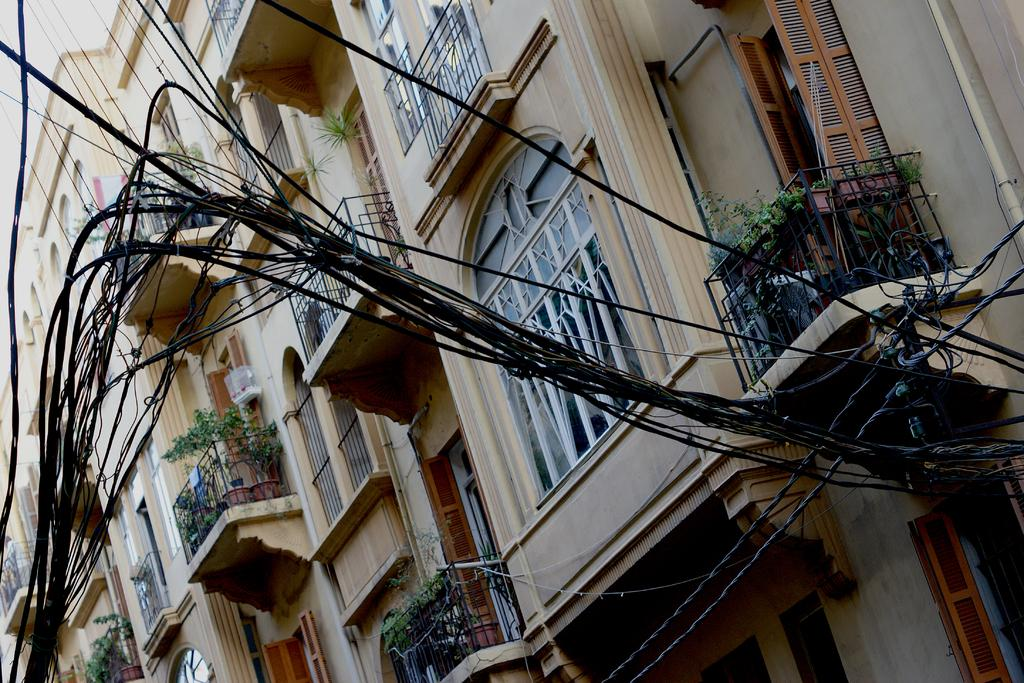What can be seen in the image that is related to electricity or communication? There are wires in the image. What is located behind the wires in the image? There are buildings behind the wires. What feature do the buildings have that indicates the presence of vegetation? The buildings have plants on them. What can be seen in the buildings that allows light to enter and people to see outside? The buildings have windows. What type of list can be seen hanging on the front of the building in the image? There is no list present in the image; it only features wires, buildings, plants, and windows. 